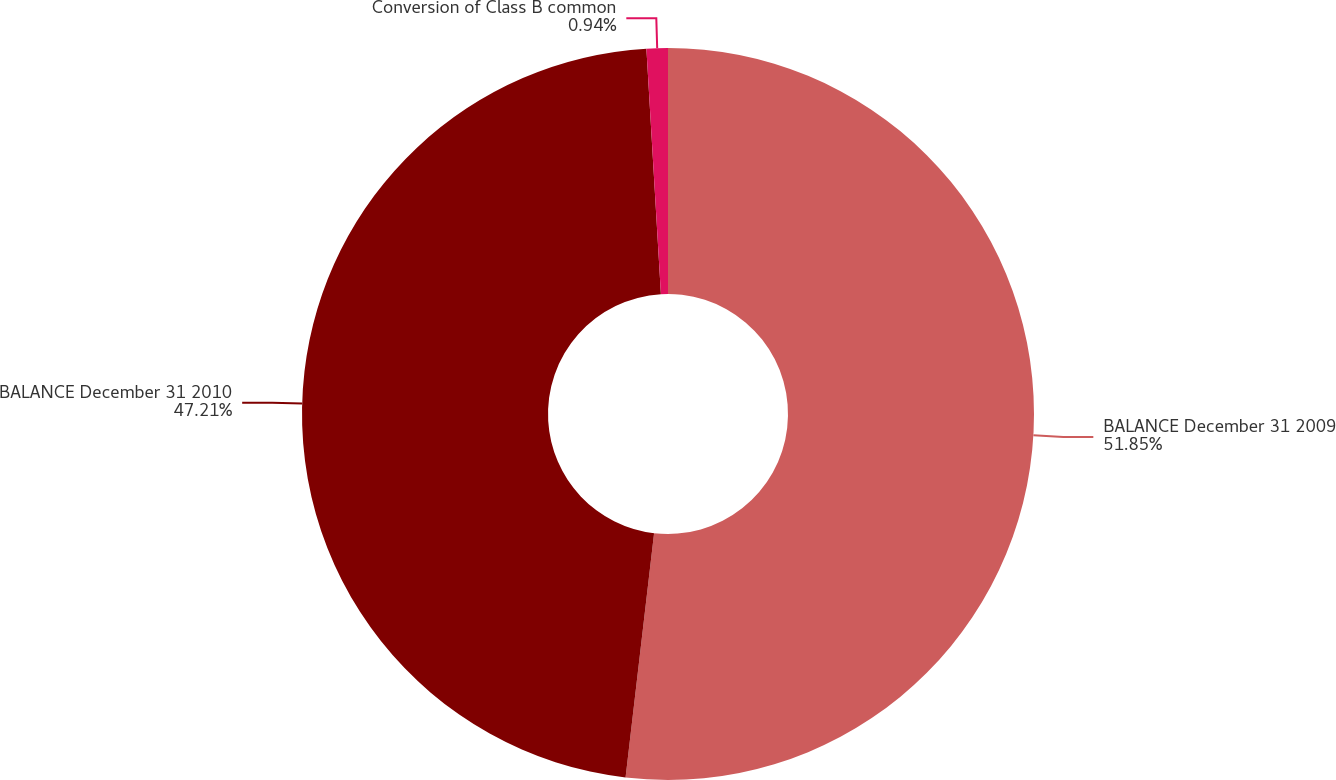Convert chart to OTSL. <chart><loc_0><loc_0><loc_500><loc_500><pie_chart><fcel>BALANCE December 31 2009<fcel>BALANCE December 31 2010<fcel>Conversion of Class B common<nl><fcel>51.85%<fcel>47.21%<fcel>0.94%<nl></chart> 